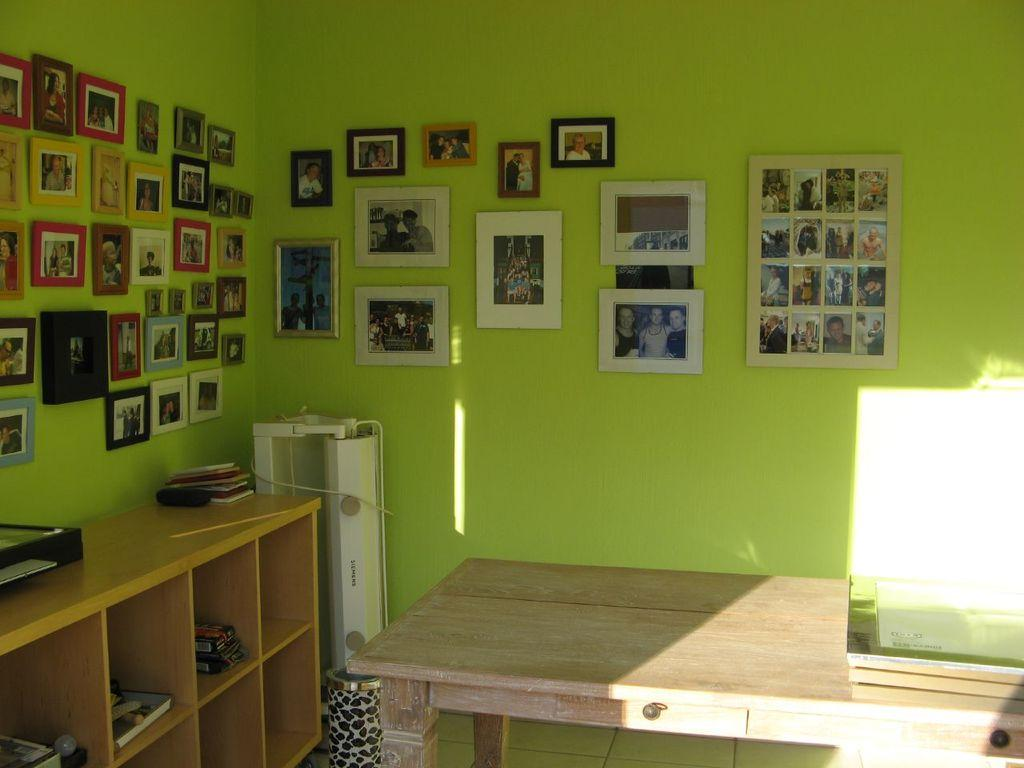What type of furniture is present in the image? There is a table in the image. What electronic device can be seen in the image? There is a device in the image. What is used for waste disposal in the image? There is a bin in the image. What type of storage is present in the image? There are wooden racks in the image. What items are stored in the wooden racks? There are books and other objects in the wooden racks. What is on the wooden surface in the image? There are objects on the wooden surface. What decorative items are present on the wall in the image? There are frames on the wall. What type of loaf is being prepared on the table in the image? There is no loaf present in the image, nor is there any indication of food preparation. What detail can be seen on the device in the image? The provided facts do not mention any specific details about the device, so we cannot answer this question. 